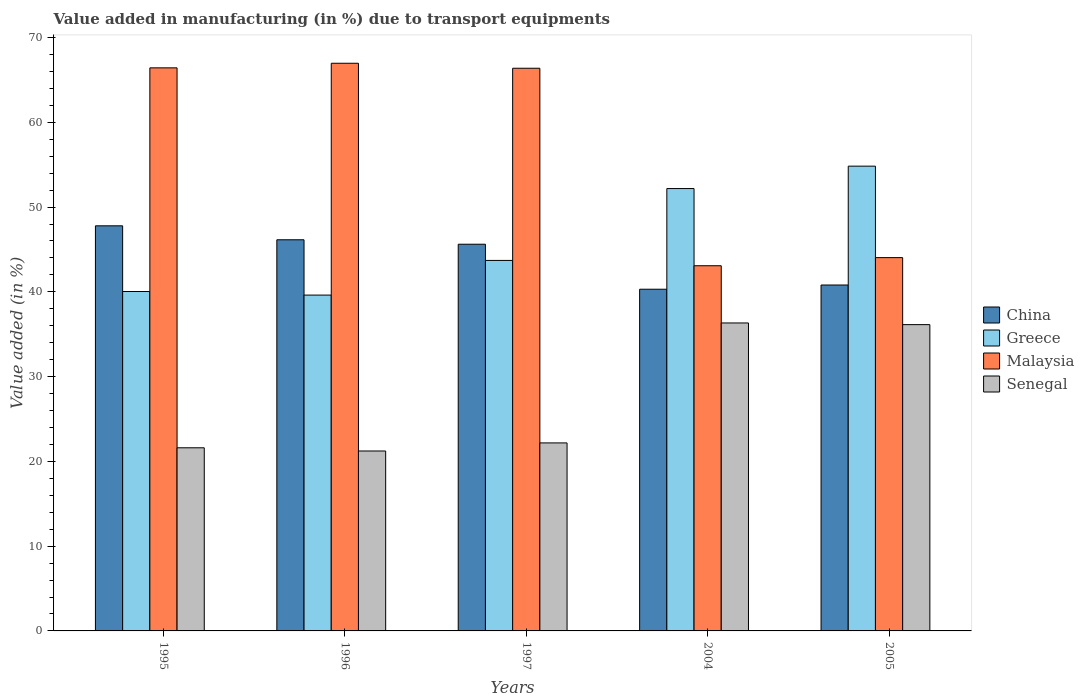Are the number of bars per tick equal to the number of legend labels?
Ensure brevity in your answer.  Yes. Are the number of bars on each tick of the X-axis equal?
Your answer should be compact. Yes. How many bars are there on the 4th tick from the left?
Keep it short and to the point. 4. How many bars are there on the 2nd tick from the right?
Provide a short and direct response. 4. What is the label of the 4th group of bars from the left?
Your response must be concise. 2004. In how many cases, is the number of bars for a given year not equal to the number of legend labels?
Provide a succinct answer. 0. What is the percentage of value added in manufacturing due to transport equipments in Senegal in 1996?
Your response must be concise. 21.23. Across all years, what is the maximum percentage of value added in manufacturing due to transport equipments in Malaysia?
Offer a terse response. 66.97. Across all years, what is the minimum percentage of value added in manufacturing due to transport equipments in China?
Ensure brevity in your answer.  40.31. In which year was the percentage of value added in manufacturing due to transport equipments in China maximum?
Your answer should be compact. 1995. What is the total percentage of value added in manufacturing due to transport equipments in Greece in the graph?
Make the answer very short. 230.38. What is the difference between the percentage of value added in manufacturing due to transport equipments in Malaysia in 1995 and that in 2005?
Make the answer very short. 22.39. What is the difference between the percentage of value added in manufacturing due to transport equipments in China in 1997 and the percentage of value added in manufacturing due to transport equipments in Senegal in 2004?
Your answer should be compact. 9.29. What is the average percentage of value added in manufacturing due to transport equipments in Malaysia per year?
Provide a succinct answer. 57.38. In the year 2005, what is the difference between the percentage of value added in manufacturing due to transport equipments in Malaysia and percentage of value added in manufacturing due to transport equipments in Greece?
Keep it short and to the point. -10.79. What is the ratio of the percentage of value added in manufacturing due to transport equipments in Greece in 1997 to that in 2005?
Make the answer very short. 0.8. What is the difference between the highest and the second highest percentage of value added in manufacturing due to transport equipments in Senegal?
Provide a succinct answer. 0.2. What is the difference between the highest and the lowest percentage of value added in manufacturing due to transport equipments in Greece?
Provide a succinct answer. 15.21. In how many years, is the percentage of value added in manufacturing due to transport equipments in Malaysia greater than the average percentage of value added in manufacturing due to transport equipments in Malaysia taken over all years?
Make the answer very short. 3. What does the 3rd bar from the right in 1997 represents?
Ensure brevity in your answer.  Greece. How many years are there in the graph?
Provide a short and direct response. 5. What is the difference between two consecutive major ticks on the Y-axis?
Provide a short and direct response. 10. Are the values on the major ticks of Y-axis written in scientific E-notation?
Offer a terse response. No. Does the graph contain any zero values?
Make the answer very short. No. Does the graph contain grids?
Keep it short and to the point. No. What is the title of the graph?
Your answer should be compact. Value added in manufacturing (in %) due to transport equipments. Does "Guyana" appear as one of the legend labels in the graph?
Provide a short and direct response. No. What is the label or title of the Y-axis?
Your answer should be very brief. Value added (in %). What is the Value added (in %) in China in 1995?
Provide a short and direct response. 47.79. What is the Value added (in %) in Greece in 1995?
Give a very brief answer. 40.04. What is the Value added (in %) of Malaysia in 1995?
Your response must be concise. 66.42. What is the Value added (in %) of Senegal in 1995?
Your answer should be very brief. 21.6. What is the Value added (in %) in China in 1996?
Your answer should be very brief. 46.14. What is the Value added (in %) of Greece in 1996?
Make the answer very short. 39.62. What is the Value added (in %) in Malaysia in 1996?
Make the answer very short. 66.97. What is the Value added (in %) of Senegal in 1996?
Provide a succinct answer. 21.23. What is the Value added (in %) in China in 1997?
Ensure brevity in your answer.  45.62. What is the Value added (in %) in Greece in 1997?
Provide a short and direct response. 43.71. What is the Value added (in %) in Malaysia in 1997?
Offer a very short reply. 66.38. What is the Value added (in %) of Senegal in 1997?
Ensure brevity in your answer.  22.18. What is the Value added (in %) in China in 2004?
Your response must be concise. 40.31. What is the Value added (in %) in Greece in 2004?
Provide a succinct answer. 52.18. What is the Value added (in %) of Malaysia in 2004?
Your response must be concise. 43.08. What is the Value added (in %) of Senegal in 2004?
Offer a very short reply. 36.33. What is the Value added (in %) of China in 2005?
Your answer should be very brief. 40.81. What is the Value added (in %) of Greece in 2005?
Your response must be concise. 54.83. What is the Value added (in %) of Malaysia in 2005?
Provide a succinct answer. 44.04. What is the Value added (in %) of Senegal in 2005?
Offer a terse response. 36.13. Across all years, what is the maximum Value added (in %) of China?
Offer a very short reply. 47.79. Across all years, what is the maximum Value added (in %) of Greece?
Offer a terse response. 54.83. Across all years, what is the maximum Value added (in %) of Malaysia?
Make the answer very short. 66.97. Across all years, what is the maximum Value added (in %) of Senegal?
Offer a very short reply. 36.33. Across all years, what is the minimum Value added (in %) of China?
Offer a terse response. 40.31. Across all years, what is the minimum Value added (in %) of Greece?
Keep it short and to the point. 39.62. Across all years, what is the minimum Value added (in %) in Malaysia?
Offer a very short reply. 43.08. Across all years, what is the minimum Value added (in %) of Senegal?
Provide a succinct answer. 21.23. What is the total Value added (in %) of China in the graph?
Give a very brief answer. 220.66. What is the total Value added (in %) in Greece in the graph?
Give a very brief answer. 230.38. What is the total Value added (in %) in Malaysia in the graph?
Make the answer very short. 286.88. What is the total Value added (in %) in Senegal in the graph?
Make the answer very short. 137.47. What is the difference between the Value added (in %) in China in 1995 and that in 1996?
Provide a succinct answer. 1.65. What is the difference between the Value added (in %) in Greece in 1995 and that in 1996?
Provide a short and direct response. 0.42. What is the difference between the Value added (in %) in Malaysia in 1995 and that in 1996?
Your answer should be compact. -0.54. What is the difference between the Value added (in %) of Senegal in 1995 and that in 1996?
Provide a succinct answer. 0.38. What is the difference between the Value added (in %) in China in 1995 and that in 1997?
Provide a succinct answer. 2.17. What is the difference between the Value added (in %) of Greece in 1995 and that in 1997?
Ensure brevity in your answer.  -3.67. What is the difference between the Value added (in %) of Malaysia in 1995 and that in 1997?
Your answer should be very brief. 0.05. What is the difference between the Value added (in %) in Senegal in 1995 and that in 1997?
Your answer should be very brief. -0.57. What is the difference between the Value added (in %) of China in 1995 and that in 2004?
Make the answer very short. 7.48. What is the difference between the Value added (in %) in Greece in 1995 and that in 2004?
Your answer should be compact. -12.14. What is the difference between the Value added (in %) in Malaysia in 1995 and that in 2004?
Make the answer very short. 23.35. What is the difference between the Value added (in %) in Senegal in 1995 and that in 2004?
Make the answer very short. -14.73. What is the difference between the Value added (in %) of China in 1995 and that in 2005?
Give a very brief answer. 6.98. What is the difference between the Value added (in %) of Greece in 1995 and that in 2005?
Ensure brevity in your answer.  -14.79. What is the difference between the Value added (in %) in Malaysia in 1995 and that in 2005?
Make the answer very short. 22.39. What is the difference between the Value added (in %) in Senegal in 1995 and that in 2005?
Keep it short and to the point. -14.53. What is the difference between the Value added (in %) in China in 1996 and that in 1997?
Ensure brevity in your answer.  0.52. What is the difference between the Value added (in %) in Greece in 1996 and that in 1997?
Provide a short and direct response. -4.09. What is the difference between the Value added (in %) of Malaysia in 1996 and that in 1997?
Your answer should be compact. 0.59. What is the difference between the Value added (in %) of Senegal in 1996 and that in 1997?
Ensure brevity in your answer.  -0.95. What is the difference between the Value added (in %) in China in 1996 and that in 2004?
Give a very brief answer. 5.83. What is the difference between the Value added (in %) of Greece in 1996 and that in 2004?
Your response must be concise. -12.57. What is the difference between the Value added (in %) of Malaysia in 1996 and that in 2004?
Give a very brief answer. 23.89. What is the difference between the Value added (in %) in Senegal in 1996 and that in 2004?
Make the answer very short. -15.1. What is the difference between the Value added (in %) in China in 1996 and that in 2005?
Your response must be concise. 5.33. What is the difference between the Value added (in %) in Greece in 1996 and that in 2005?
Your answer should be compact. -15.21. What is the difference between the Value added (in %) in Malaysia in 1996 and that in 2005?
Provide a short and direct response. 22.93. What is the difference between the Value added (in %) of Senegal in 1996 and that in 2005?
Give a very brief answer. -14.9. What is the difference between the Value added (in %) in China in 1997 and that in 2004?
Your answer should be very brief. 5.31. What is the difference between the Value added (in %) of Greece in 1997 and that in 2004?
Your response must be concise. -8.48. What is the difference between the Value added (in %) of Malaysia in 1997 and that in 2004?
Your answer should be very brief. 23.3. What is the difference between the Value added (in %) of Senegal in 1997 and that in 2004?
Your answer should be very brief. -14.15. What is the difference between the Value added (in %) of China in 1997 and that in 2005?
Offer a very short reply. 4.81. What is the difference between the Value added (in %) in Greece in 1997 and that in 2005?
Your response must be concise. -11.12. What is the difference between the Value added (in %) in Malaysia in 1997 and that in 2005?
Provide a short and direct response. 22.34. What is the difference between the Value added (in %) in Senegal in 1997 and that in 2005?
Ensure brevity in your answer.  -13.95. What is the difference between the Value added (in %) in China in 2004 and that in 2005?
Ensure brevity in your answer.  -0.5. What is the difference between the Value added (in %) in Greece in 2004 and that in 2005?
Offer a terse response. -2.64. What is the difference between the Value added (in %) in Malaysia in 2004 and that in 2005?
Keep it short and to the point. -0.96. What is the difference between the Value added (in %) of Senegal in 2004 and that in 2005?
Ensure brevity in your answer.  0.2. What is the difference between the Value added (in %) of China in 1995 and the Value added (in %) of Greece in 1996?
Offer a very short reply. 8.17. What is the difference between the Value added (in %) of China in 1995 and the Value added (in %) of Malaysia in 1996?
Keep it short and to the point. -19.18. What is the difference between the Value added (in %) in China in 1995 and the Value added (in %) in Senegal in 1996?
Keep it short and to the point. 26.56. What is the difference between the Value added (in %) of Greece in 1995 and the Value added (in %) of Malaysia in 1996?
Your answer should be compact. -26.93. What is the difference between the Value added (in %) of Greece in 1995 and the Value added (in %) of Senegal in 1996?
Your answer should be very brief. 18.81. What is the difference between the Value added (in %) in Malaysia in 1995 and the Value added (in %) in Senegal in 1996?
Your response must be concise. 45.2. What is the difference between the Value added (in %) in China in 1995 and the Value added (in %) in Greece in 1997?
Offer a terse response. 4.08. What is the difference between the Value added (in %) of China in 1995 and the Value added (in %) of Malaysia in 1997?
Make the answer very short. -18.59. What is the difference between the Value added (in %) in China in 1995 and the Value added (in %) in Senegal in 1997?
Provide a short and direct response. 25.61. What is the difference between the Value added (in %) in Greece in 1995 and the Value added (in %) in Malaysia in 1997?
Your answer should be very brief. -26.34. What is the difference between the Value added (in %) in Greece in 1995 and the Value added (in %) in Senegal in 1997?
Provide a succinct answer. 17.86. What is the difference between the Value added (in %) of Malaysia in 1995 and the Value added (in %) of Senegal in 1997?
Offer a very short reply. 44.25. What is the difference between the Value added (in %) in China in 1995 and the Value added (in %) in Greece in 2004?
Keep it short and to the point. -4.4. What is the difference between the Value added (in %) in China in 1995 and the Value added (in %) in Malaysia in 2004?
Make the answer very short. 4.71. What is the difference between the Value added (in %) in China in 1995 and the Value added (in %) in Senegal in 2004?
Provide a succinct answer. 11.46. What is the difference between the Value added (in %) in Greece in 1995 and the Value added (in %) in Malaysia in 2004?
Keep it short and to the point. -3.04. What is the difference between the Value added (in %) in Greece in 1995 and the Value added (in %) in Senegal in 2004?
Offer a very short reply. 3.71. What is the difference between the Value added (in %) in Malaysia in 1995 and the Value added (in %) in Senegal in 2004?
Give a very brief answer. 30.1. What is the difference between the Value added (in %) of China in 1995 and the Value added (in %) of Greece in 2005?
Provide a succinct answer. -7.04. What is the difference between the Value added (in %) in China in 1995 and the Value added (in %) in Malaysia in 2005?
Offer a very short reply. 3.75. What is the difference between the Value added (in %) in China in 1995 and the Value added (in %) in Senegal in 2005?
Keep it short and to the point. 11.66. What is the difference between the Value added (in %) in Greece in 1995 and the Value added (in %) in Malaysia in 2005?
Provide a short and direct response. -4. What is the difference between the Value added (in %) in Greece in 1995 and the Value added (in %) in Senegal in 2005?
Keep it short and to the point. 3.91. What is the difference between the Value added (in %) in Malaysia in 1995 and the Value added (in %) in Senegal in 2005?
Your response must be concise. 30.29. What is the difference between the Value added (in %) of China in 1996 and the Value added (in %) of Greece in 1997?
Offer a very short reply. 2.44. What is the difference between the Value added (in %) in China in 1996 and the Value added (in %) in Malaysia in 1997?
Make the answer very short. -20.24. What is the difference between the Value added (in %) of China in 1996 and the Value added (in %) of Senegal in 1997?
Ensure brevity in your answer.  23.96. What is the difference between the Value added (in %) in Greece in 1996 and the Value added (in %) in Malaysia in 1997?
Provide a succinct answer. -26.76. What is the difference between the Value added (in %) of Greece in 1996 and the Value added (in %) of Senegal in 1997?
Your response must be concise. 17.44. What is the difference between the Value added (in %) of Malaysia in 1996 and the Value added (in %) of Senegal in 1997?
Offer a terse response. 44.79. What is the difference between the Value added (in %) in China in 1996 and the Value added (in %) in Greece in 2004?
Provide a short and direct response. -6.04. What is the difference between the Value added (in %) of China in 1996 and the Value added (in %) of Malaysia in 2004?
Give a very brief answer. 3.06. What is the difference between the Value added (in %) of China in 1996 and the Value added (in %) of Senegal in 2004?
Your answer should be compact. 9.81. What is the difference between the Value added (in %) in Greece in 1996 and the Value added (in %) in Malaysia in 2004?
Offer a very short reply. -3.46. What is the difference between the Value added (in %) of Greece in 1996 and the Value added (in %) of Senegal in 2004?
Your response must be concise. 3.29. What is the difference between the Value added (in %) in Malaysia in 1996 and the Value added (in %) in Senegal in 2004?
Your answer should be very brief. 30.64. What is the difference between the Value added (in %) of China in 1996 and the Value added (in %) of Greece in 2005?
Your answer should be very brief. -8.69. What is the difference between the Value added (in %) in China in 1996 and the Value added (in %) in Malaysia in 2005?
Offer a terse response. 2.1. What is the difference between the Value added (in %) in China in 1996 and the Value added (in %) in Senegal in 2005?
Offer a very short reply. 10.01. What is the difference between the Value added (in %) in Greece in 1996 and the Value added (in %) in Malaysia in 2005?
Offer a terse response. -4.42. What is the difference between the Value added (in %) in Greece in 1996 and the Value added (in %) in Senegal in 2005?
Make the answer very short. 3.49. What is the difference between the Value added (in %) in Malaysia in 1996 and the Value added (in %) in Senegal in 2005?
Your answer should be very brief. 30.83. What is the difference between the Value added (in %) of China in 1997 and the Value added (in %) of Greece in 2004?
Offer a terse response. -6.57. What is the difference between the Value added (in %) of China in 1997 and the Value added (in %) of Malaysia in 2004?
Provide a short and direct response. 2.54. What is the difference between the Value added (in %) of China in 1997 and the Value added (in %) of Senegal in 2004?
Give a very brief answer. 9.29. What is the difference between the Value added (in %) in Greece in 1997 and the Value added (in %) in Malaysia in 2004?
Your answer should be compact. 0.63. What is the difference between the Value added (in %) of Greece in 1997 and the Value added (in %) of Senegal in 2004?
Give a very brief answer. 7.38. What is the difference between the Value added (in %) of Malaysia in 1997 and the Value added (in %) of Senegal in 2004?
Give a very brief answer. 30.05. What is the difference between the Value added (in %) in China in 1997 and the Value added (in %) in Greece in 2005?
Offer a very short reply. -9.21. What is the difference between the Value added (in %) of China in 1997 and the Value added (in %) of Malaysia in 2005?
Make the answer very short. 1.58. What is the difference between the Value added (in %) in China in 1997 and the Value added (in %) in Senegal in 2005?
Keep it short and to the point. 9.49. What is the difference between the Value added (in %) in Greece in 1997 and the Value added (in %) in Malaysia in 2005?
Your answer should be very brief. -0.33. What is the difference between the Value added (in %) of Greece in 1997 and the Value added (in %) of Senegal in 2005?
Your answer should be very brief. 7.57. What is the difference between the Value added (in %) of Malaysia in 1997 and the Value added (in %) of Senegal in 2005?
Your answer should be very brief. 30.25. What is the difference between the Value added (in %) of China in 2004 and the Value added (in %) of Greece in 2005?
Provide a succinct answer. -14.52. What is the difference between the Value added (in %) in China in 2004 and the Value added (in %) in Malaysia in 2005?
Offer a very short reply. -3.73. What is the difference between the Value added (in %) in China in 2004 and the Value added (in %) in Senegal in 2005?
Your answer should be very brief. 4.18. What is the difference between the Value added (in %) in Greece in 2004 and the Value added (in %) in Malaysia in 2005?
Make the answer very short. 8.15. What is the difference between the Value added (in %) of Greece in 2004 and the Value added (in %) of Senegal in 2005?
Provide a short and direct response. 16.05. What is the difference between the Value added (in %) of Malaysia in 2004 and the Value added (in %) of Senegal in 2005?
Your answer should be compact. 6.95. What is the average Value added (in %) in China per year?
Keep it short and to the point. 44.13. What is the average Value added (in %) in Greece per year?
Give a very brief answer. 46.08. What is the average Value added (in %) in Malaysia per year?
Give a very brief answer. 57.38. What is the average Value added (in %) of Senegal per year?
Give a very brief answer. 27.49. In the year 1995, what is the difference between the Value added (in %) in China and Value added (in %) in Greece?
Offer a very short reply. 7.75. In the year 1995, what is the difference between the Value added (in %) of China and Value added (in %) of Malaysia?
Your answer should be compact. -18.64. In the year 1995, what is the difference between the Value added (in %) in China and Value added (in %) in Senegal?
Offer a terse response. 26.19. In the year 1995, what is the difference between the Value added (in %) of Greece and Value added (in %) of Malaysia?
Keep it short and to the point. -26.38. In the year 1995, what is the difference between the Value added (in %) in Greece and Value added (in %) in Senegal?
Offer a terse response. 18.44. In the year 1995, what is the difference between the Value added (in %) of Malaysia and Value added (in %) of Senegal?
Keep it short and to the point. 44.82. In the year 1996, what is the difference between the Value added (in %) in China and Value added (in %) in Greece?
Your answer should be very brief. 6.52. In the year 1996, what is the difference between the Value added (in %) of China and Value added (in %) of Malaysia?
Offer a terse response. -20.82. In the year 1996, what is the difference between the Value added (in %) of China and Value added (in %) of Senegal?
Provide a short and direct response. 24.92. In the year 1996, what is the difference between the Value added (in %) in Greece and Value added (in %) in Malaysia?
Your answer should be compact. -27.35. In the year 1996, what is the difference between the Value added (in %) of Greece and Value added (in %) of Senegal?
Offer a very short reply. 18.39. In the year 1996, what is the difference between the Value added (in %) of Malaysia and Value added (in %) of Senegal?
Keep it short and to the point. 45.74. In the year 1997, what is the difference between the Value added (in %) of China and Value added (in %) of Greece?
Your answer should be compact. 1.91. In the year 1997, what is the difference between the Value added (in %) of China and Value added (in %) of Malaysia?
Provide a short and direct response. -20.76. In the year 1997, what is the difference between the Value added (in %) in China and Value added (in %) in Senegal?
Provide a succinct answer. 23.44. In the year 1997, what is the difference between the Value added (in %) in Greece and Value added (in %) in Malaysia?
Make the answer very short. -22.67. In the year 1997, what is the difference between the Value added (in %) in Greece and Value added (in %) in Senegal?
Your response must be concise. 21.53. In the year 1997, what is the difference between the Value added (in %) of Malaysia and Value added (in %) of Senegal?
Offer a very short reply. 44.2. In the year 2004, what is the difference between the Value added (in %) of China and Value added (in %) of Greece?
Offer a very short reply. -11.88. In the year 2004, what is the difference between the Value added (in %) in China and Value added (in %) in Malaysia?
Make the answer very short. -2.77. In the year 2004, what is the difference between the Value added (in %) of China and Value added (in %) of Senegal?
Your answer should be compact. 3.98. In the year 2004, what is the difference between the Value added (in %) in Greece and Value added (in %) in Malaysia?
Provide a succinct answer. 9.11. In the year 2004, what is the difference between the Value added (in %) of Greece and Value added (in %) of Senegal?
Keep it short and to the point. 15.86. In the year 2004, what is the difference between the Value added (in %) in Malaysia and Value added (in %) in Senegal?
Provide a short and direct response. 6.75. In the year 2005, what is the difference between the Value added (in %) in China and Value added (in %) in Greece?
Keep it short and to the point. -14.02. In the year 2005, what is the difference between the Value added (in %) in China and Value added (in %) in Malaysia?
Keep it short and to the point. -3.23. In the year 2005, what is the difference between the Value added (in %) in China and Value added (in %) in Senegal?
Ensure brevity in your answer.  4.68. In the year 2005, what is the difference between the Value added (in %) in Greece and Value added (in %) in Malaysia?
Offer a very short reply. 10.79. In the year 2005, what is the difference between the Value added (in %) in Greece and Value added (in %) in Senegal?
Your answer should be very brief. 18.7. In the year 2005, what is the difference between the Value added (in %) in Malaysia and Value added (in %) in Senegal?
Your answer should be compact. 7.91. What is the ratio of the Value added (in %) in China in 1995 to that in 1996?
Make the answer very short. 1.04. What is the ratio of the Value added (in %) in Greece in 1995 to that in 1996?
Offer a terse response. 1.01. What is the ratio of the Value added (in %) in Malaysia in 1995 to that in 1996?
Provide a succinct answer. 0.99. What is the ratio of the Value added (in %) of Senegal in 1995 to that in 1996?
Make the answer very short. 1.02. What is the ratio of the Value added (in %) of China in 1995 to that in 1997?
Offer a very short reply. 1.05. What is the ratio of the Value added (in %) in Greece in 1995 to that in 1997?
Provide a succinct answer. 0.92. What is the ratio of the Value added (in %) of Malaysia in 1995 to that in 1997?
Your answer should be compact. 1. What is the ratio of the Value added (in %) of Senegal in 1995 to that in 1997?
Keep it short and to the point. 0.97. What is the ratio of the Value added (in %) of China in 1995 to that in 2004?
Offer a very short reply. 1.19. What is the ratio of the Value added (in %) in Greece in 1995 to that in 2004?
Make the answer very short. 0.77. What is the ratio of the Value added (in %) in Malaysia in 1995 to that in 2004?
Provide a succinct answer. 1.54. What is the ratio of the Value added (in %) in Senegal in 1995 to that in 2004?
Your answer should be very brief. 0.59. What is the ratio of the Value added (in %) of China in 1995 to that in 2005?
Your response must be concise. 1.17. What is the ratio of the Value added (in %) of Greece in 1995 to that in 2005?
Make the answer very short. 0.73. What is the ratio of the Value added (in %) of Malaysia in 1995 to that in 2005?
Keep it short and to the point. 1.51. What is the ratio of the Value added (in %) in Senegal in 1995 to that in 2005?
Offer a very short reply. 0.6. What is the ratio of the Value added (in %) in China in 1996 to that in 1997?
Offer a terse response. 1.01. What is the ratio of the Value added (in %) in Greece in 1996 to that in 1997?
Keep it short and to the point. 0.91. What is the ratio of the Value added (in %) of Malaysia in 1996 to that in 1997?
Your answer should be compact. 1.01. What is the ratio of the Value added (in %) in Senegal in 1996 to that in 1997?
Your answer should be compact. 0.96. What is the ratio of the Value added (in %) in China in 1996 to that in 2004?
Your answer should be very brief. 1.14. What is the ratio of the Value added (in %) of Greece in 1996 to that in 2004?
Make the answer very short. 0.76. What is the ratio of the Value added (in %) of Malaysia in 1996 to that in 2004?
Your answer should be very brief. 1.55. What is the ratio of the Value added (in %) of Senegal in 1996 to that in 2004?
Provide a short and direct response. 0.58. What is the ratio of the Value added (in %) in China in 1996 to that in 2005?
Your response must be concise. 1.13. What is the ratio of the Value added (in %) of Greece in 1996 to that in 2005?
Make the answer very short. 0.72. What is the ratio of the Value added (in %) of Malaysia in 1996 to that in 2005?
Offer a very short reply. 1.52. What is the ratio of the Value added (in %) of Senegal in 1996 to that in 2005?
Make the answer very short. 0.59. What is the ratio of the Value added (in %) in China in 1997 to that in 2004?
Ensure brevity in your answer.  1.13. What is the ratio of the Value added (in %) of Greece in 1997 to that in 2004?
Give a very brief answer. 0.84. What is the ratio of the Value added (in %) in Malaysia in 1997 to that in 2004?
Offer a terse response. 1.54. What is the ratio of the Value added (in %) of Senegal in 1997 to that in 2004?
Ensure brevity in your answer.  0.61. What is the ratio of the Value added (in %) in China in 1997 to that in 2005?
Offer a terse response. 1.12. What is the ratio of the Value added (in %) of Greece in 1997 to that in 2005?
Your response must be concise. 0.8. What is the ratio of the Value added (in %) of Malaysia in 1997 to that in 2005?
Your answer should be very brief. 1.51. What is the ratio of the Value added (in %) in Senegal in 1997 to that in 2005?
Provide a short and direct response. 0.61. What is the ratio of the Value added (in %) of China in 2004 to that in 2005?
Provide a succinct answer. 0.99. What is the ratio of the Value added (in %) of Greece in 2004 to that in 2005?
Provide a short and direct response. 0.95. What is the ratio of the Value added (in %) in Malaysia in 2004 to that in 2005?
Provide a succinct answer. 0.98. What is the difference between the highest and the second highest Value added (in %) in China?
Offer a very short reply. 1.65. What is the difference between the highest and the second highest Value added (in %) in Greece?
Ensure brevity in your answer.  2.64. What is the difference between the highest and the second highest Value added (in %) in Malaysia?
Your response must be concise. 0.54. What is the difference between the highest and the second highest Value added (in %) in Senegal?
Give a very brief answer. 0.2. What is the difference between the highest and the lowest Value added (in %) in China?
Your answer should be very brief. 7.48. What is the difference between the highest and the lowest Value added (in %) of Greece?
Your answer should be very brief. 15.21. What is the difference between the highest and the lowest Value added (in %) of Malaysia?
Your answer should be very brief. 23.89. What is the difference between the highest and the lowest Value added (in %) in Senegal?
Offer a very short reply. 15.1. 